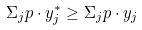Convert formula to latex. <formula><loc_0><loc_0><loc_500><loc_500>\Sigma _ { j } p \cdot y _ { j } ^ { * } \geq \Sigma _ { j } p \cdot y _ { j }</formula> 